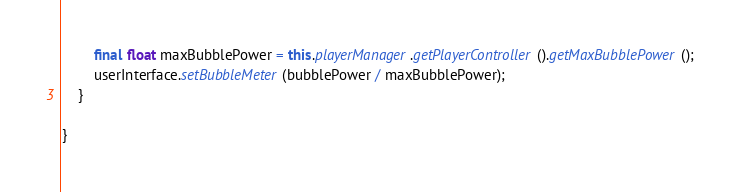Convert code to text. <code><loc_0><loc_0><loc_500><loc_500><_Java_>		final float maxBubblePower = this.playerManager.getPlayerController().getMaxBubblePower();
		userInterface.setBubbleMeter(bubblePower / maxBubblePower);
	}

}
</code> 